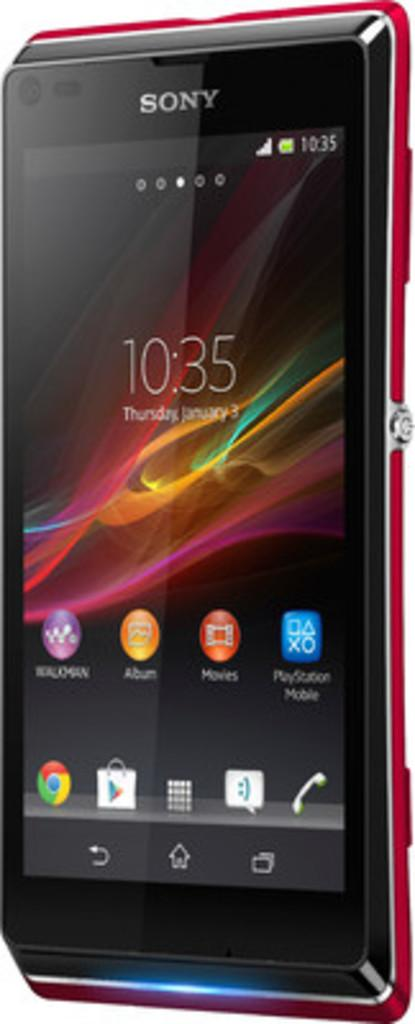<image>
Give a short and clear explanation of the subsequent image. a phone with the time on it which reads 10:35 